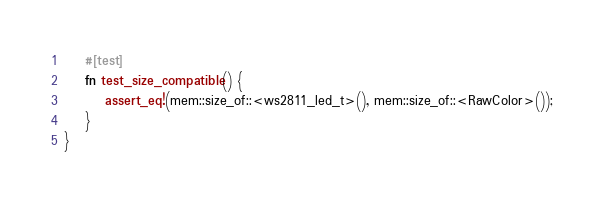Convert code to text. <code><loc_0><loc_0><loc_500><loc_500><_Rust_>    #[test]
    fn test_size_compatible() {
        assert_eq!(mem::size_of::<ws2811_led_t>(), mem::size_of::<RawColor>());
    }
}
</code> 